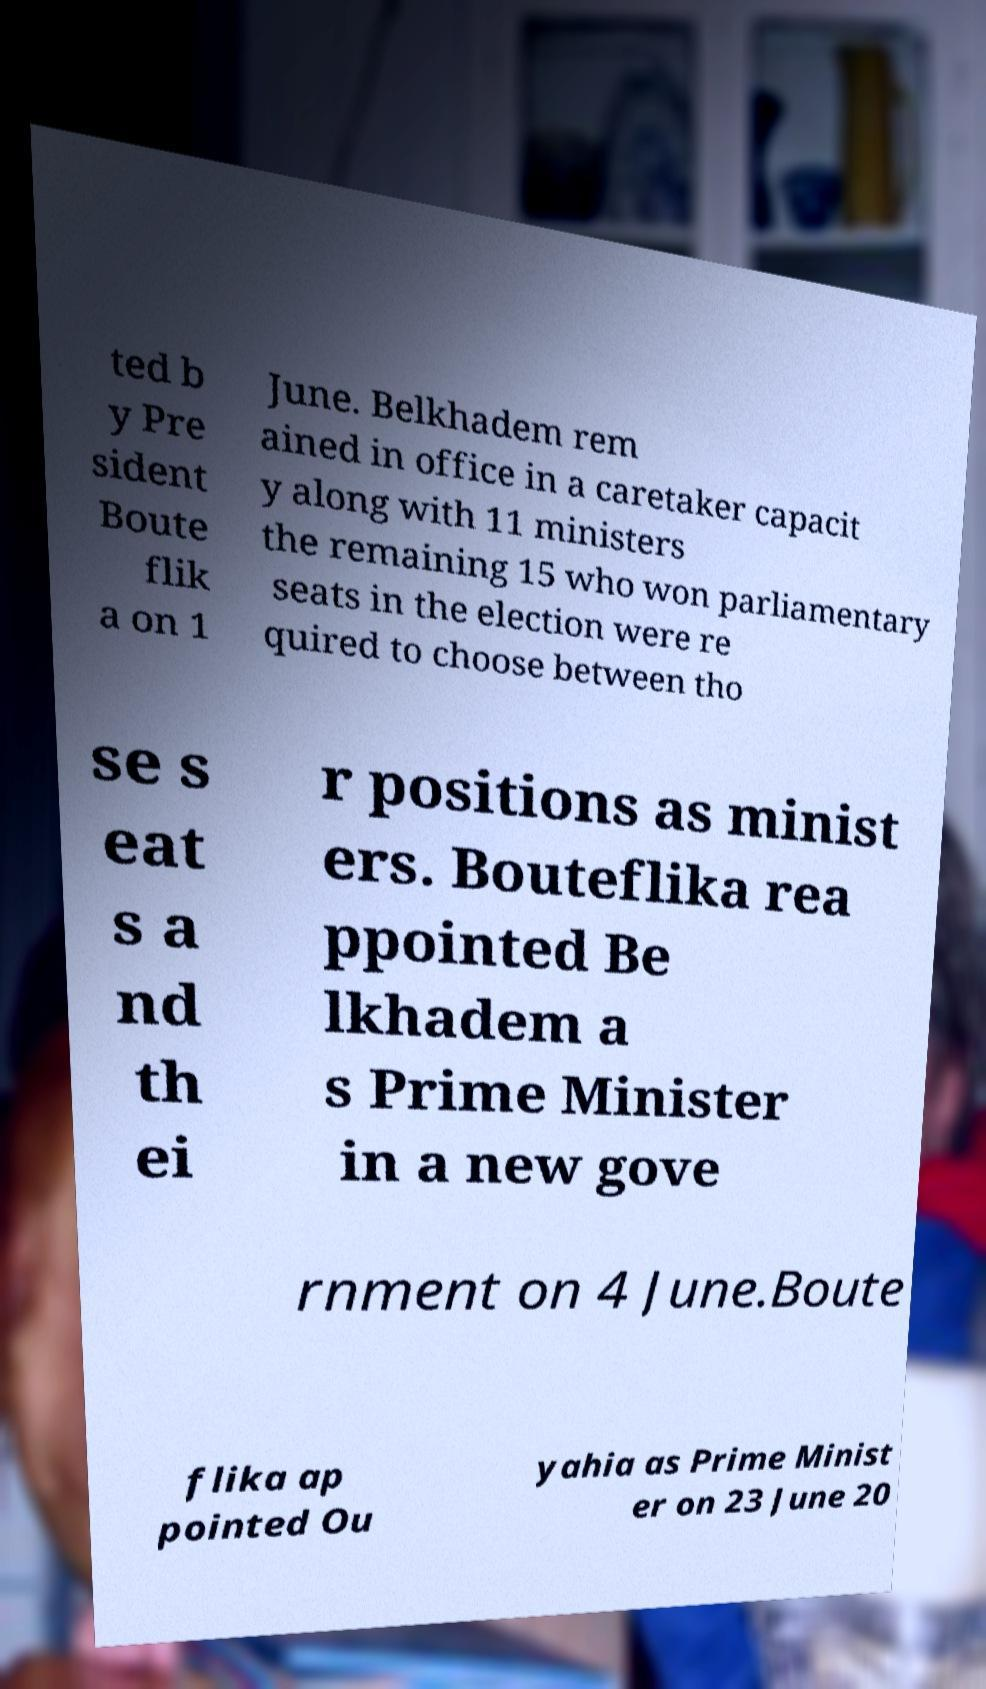Please read and relay the text visible in this image. What does it say? ted b y Pre sident Boute flik a on 1 June. Belkhadem rem ained in office in a caretaker capacit y along with 11 ministers the remaining 15 who won parliamentary seats in the election were re quired to choose between tho se s eat s a nd th ei r positions as minist ers. Bouteflika rea ppointed Be lkhadem a s Prime Minister in a new gove rnment on 4 June.Boute flika ap pointed Ou yahia as Prime Minist er on 23 June 20 